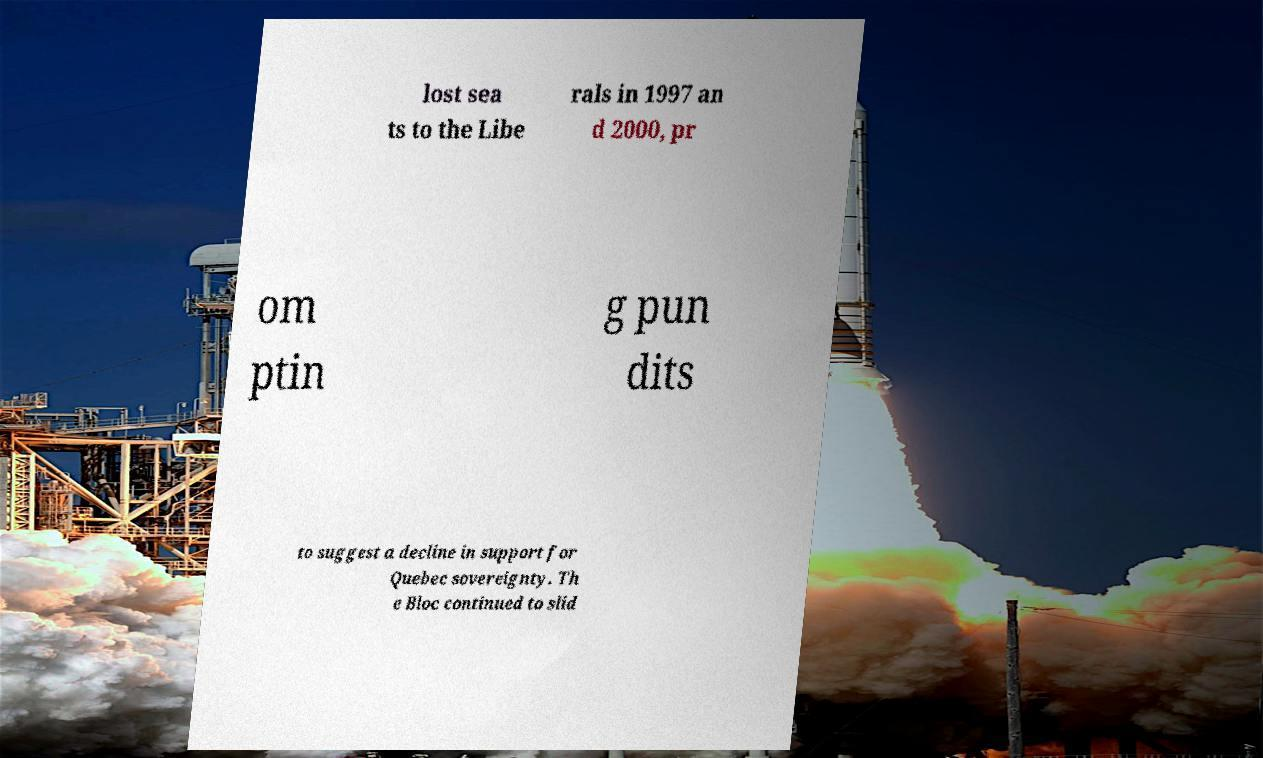Can you accurately transcribe the text from the provided image for me? lost sea ts to the Libe rals in 1997 an d 2000, pr om ptin g pun dits to suggest a decline in support for Quebec sovereignty. Th e Bloc continued to slid 